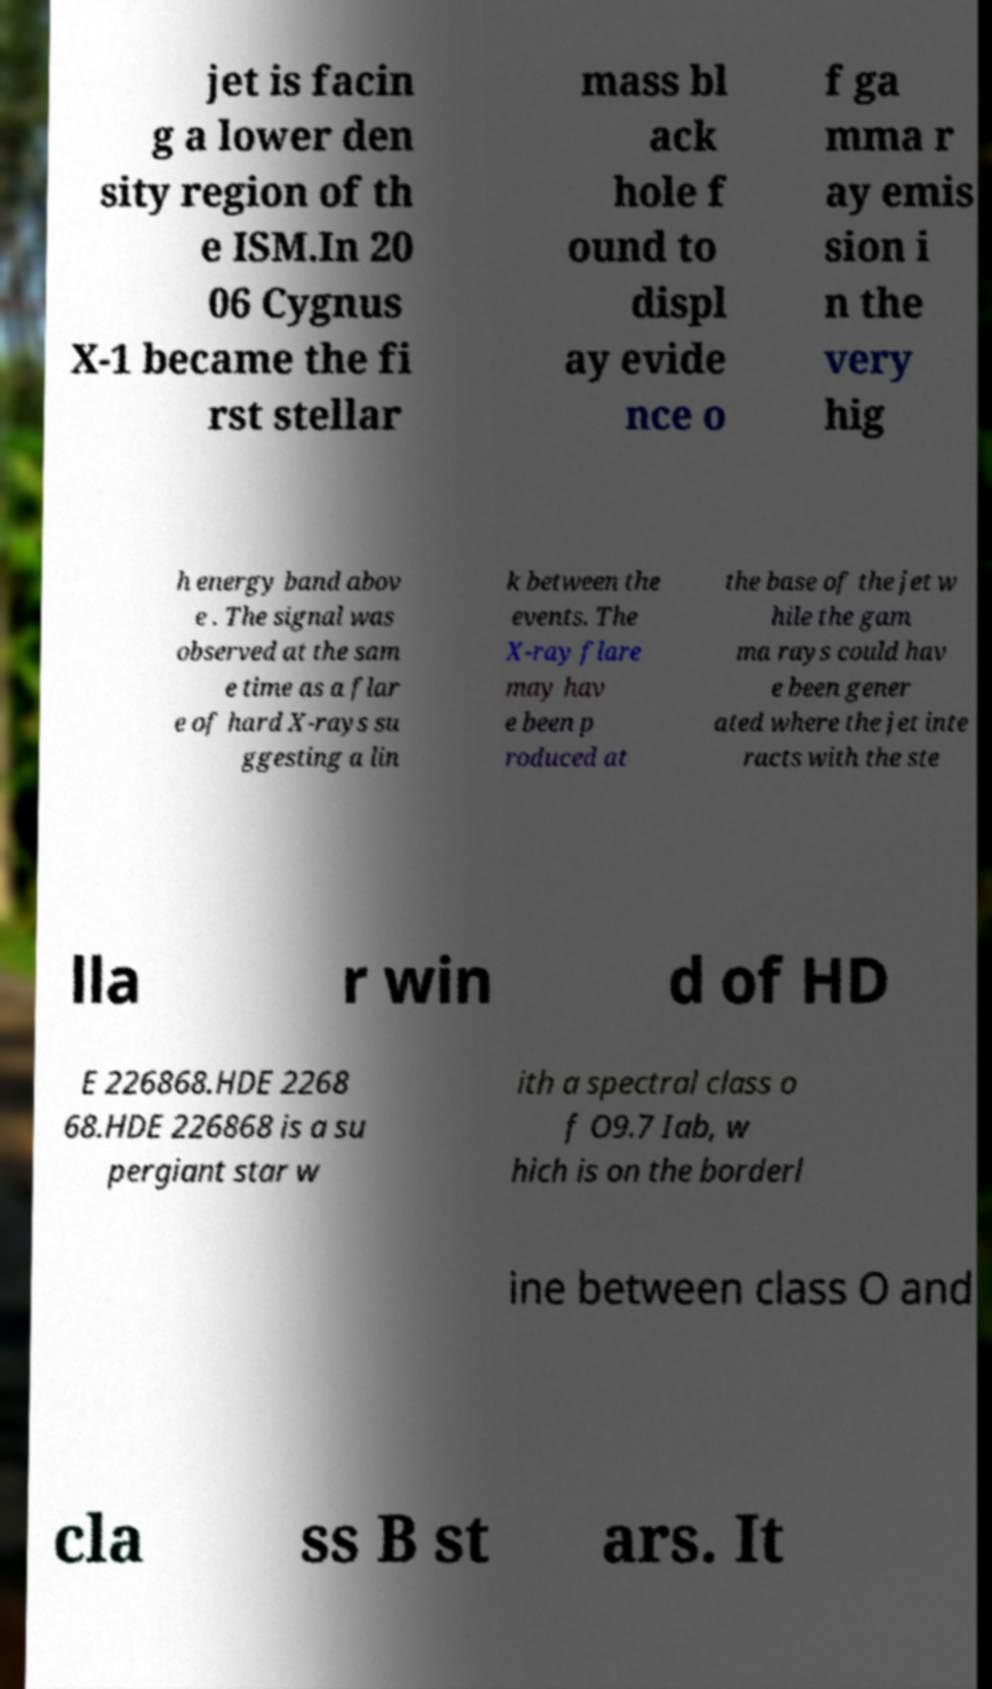For documentation purposes, I need the text within this image transcribed. Could you provide that? jet is facin g a lower den sity region of th e ISM.In 20 06 Cygnus X-1 became the fi rst stellar mass bl ack hole f ound to displ ay evide nce o f ga mma r ay emis sion i n the very hig h energy band abov e . The signal was observed at the sam e time as a flar e of hard X-rays su ggesting a lin k between the events. The X-ray flare may hav e been p roduced at the base of the jet w hile the gam ma rays could hav e been gener ated where the jet inte racts with the ste lla r win d of HD E 226868.HDE 2268 68.HDE 226868 is a su pergiant star w ith a spectral class o f O9.7 Iab, w hich is on the borderl ine between class O and cla ss B st ars. It 